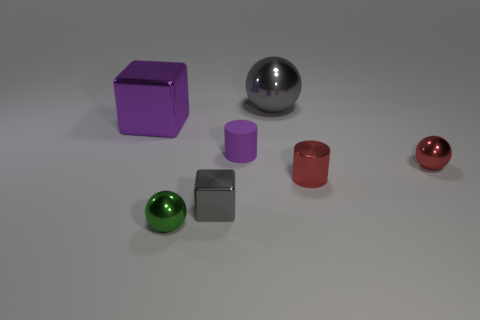Is the cylinder behind the tiny metallic cylinder made of the same material as the sphere that is behind the purple metal thing?
Give a very brief answer. No. How many other objects are the same color as the small rubber cylinder?
Ensure brevity in your answer.  1. How many things are either things behind the small green sphere or gray metallic things that are on the right side of the tiny matte thing?
Provide a short and direct response. 6. How big is the gray shiny block that is to the right of the small sphere that is to the left of the tiny purple object?
Your response must be concise. Small. What is the size of the purple metallic block?
Give a very brief answer. Large. Does the cylinder that is to the right of the tiny purple cylinder have the same color as the sphere that is to the left of the large gray ball?
Offer a very short reply. No. What number of other things are made of the same material as the small purple object?
Give a very brief answer. 0. Are there any tiny gray blocks?
Provide a short and direct response. Yes. Does the big gray ball to the left of the metallic cylinder have the same material as the small green thing?
Keep it short and to the point. Yes. What material is the red object that is the same shape as the small green object?
Ensure brevity in your answer.  Metal. 